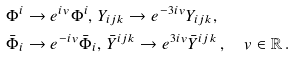<formula> <loc_0><loc_0><loc_500><loc_500>& \Phi ^ { i } \rightarrow e ^ { i v } \Phi ^ { i } , \, Y _ { i j k } \rightarrow e ^ { - 3 i v } Y _ { i j k } , \\ & \bar { \Phi } _ { i } \rightarrow e ^ { - i v } \bar { \Phi } _ { i } , \, \bar { Y } ^ { i j k } \rightarrow e ^ { 3 i v } \bar { Y } ^ { i j k } \, , \quad v \in { \mathbb { R } } \, .</formula> 